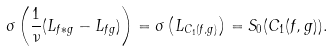<formula> <loc_0><loc_0><loc_500><loc_500>\sigma \left ( \frac { 1 } { \nu } ( L _ { f \ast g } - L _ { f g } ) \right ) = \sigma \left ( L _ { C _ { 1 } ( f , g ) } \right ) = S _ { 0 } ( C _ { 1 } ( f , g ) ) .</formula> 